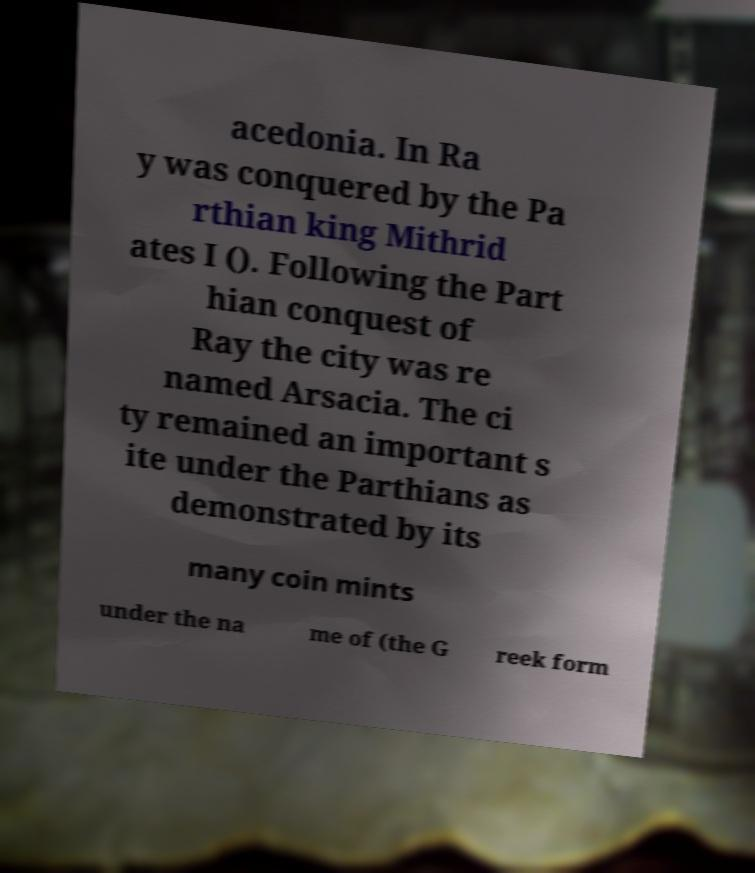Please identify and transcribe the text found in this image. acedonia. In Ra y was conquered by the Pa rthian king Mithrid ates I (). Following the Part hian conquest of Ray the city was re named Arsacia. The ci ty remained an important s ite under the Parthians as demonstrated by its many coin mints under the na me of (the G reek form 